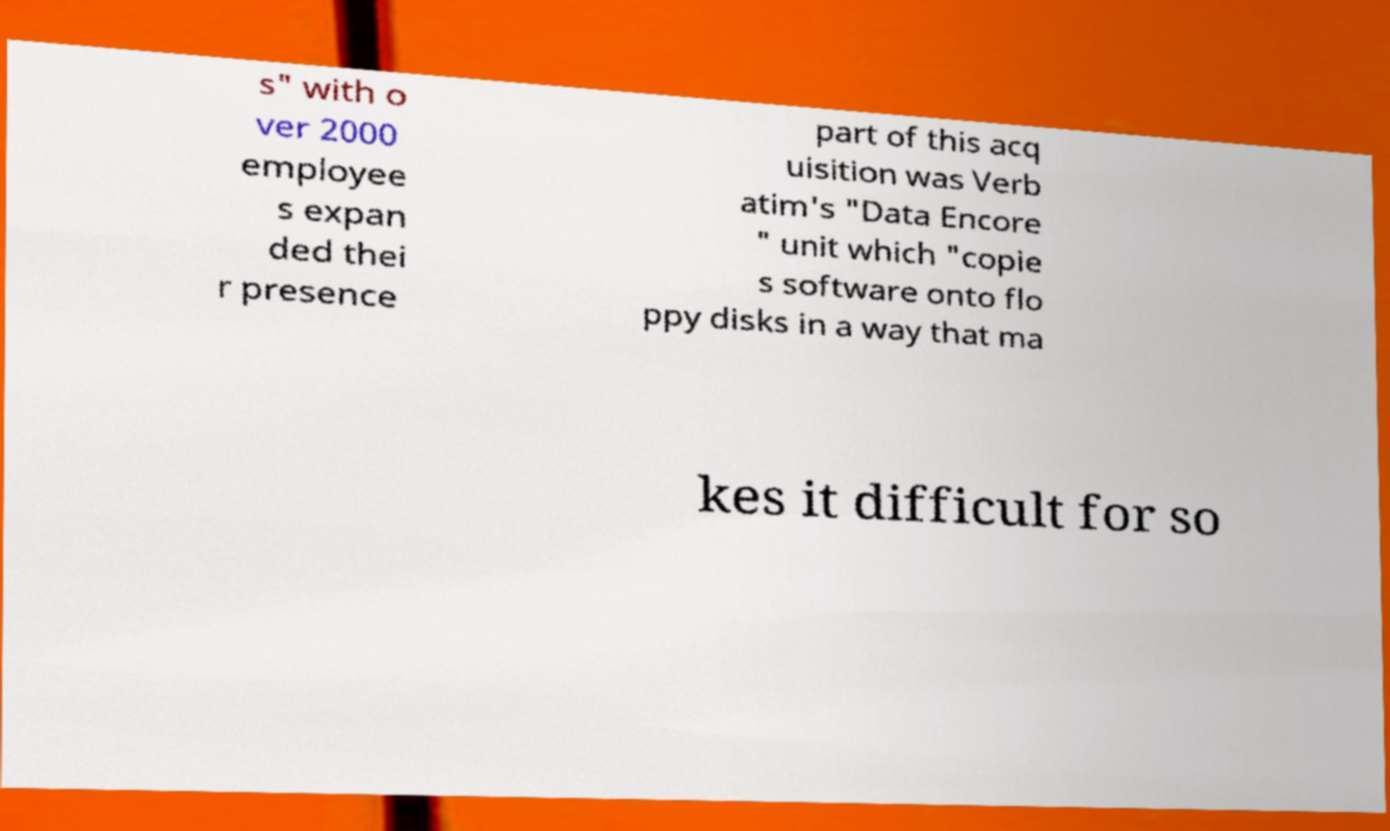Could you extract and type out the text from this image? s" with o ver 2000 employee s expan ded thei r presence part of this acq uisition was Verb atim's "Data Encore " unit which "copie s software onto flo ppy disks in a way that ma kes it difficult for so 